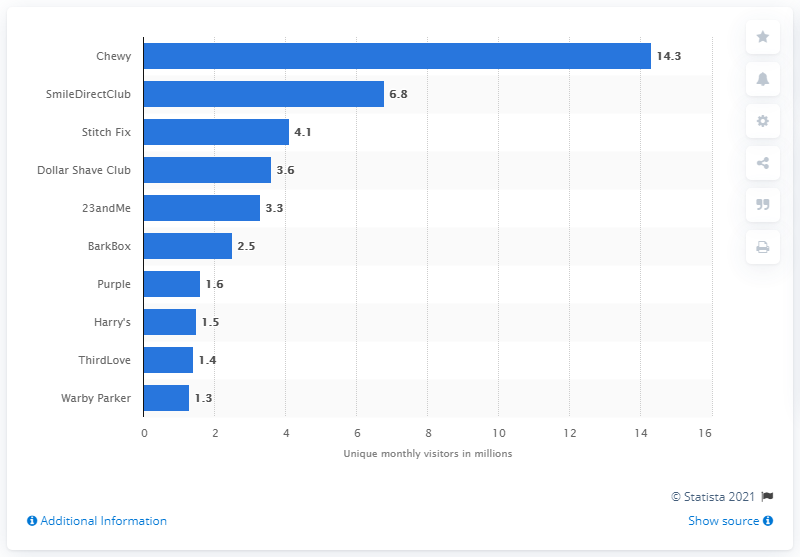Identify some key points in this picture. Chewy is the most popular D2C (Direct-to-Consumer) brand in the US. According to Chewy's rankings, SmileDirectClub is considered a higher-ranked online fashion brand than Stitch Fix. Chewy receives an average of 14,300 unique visitors per month. SmileDirectClub was ranked ahead of a personal care brand named Chewy in a ranking. 